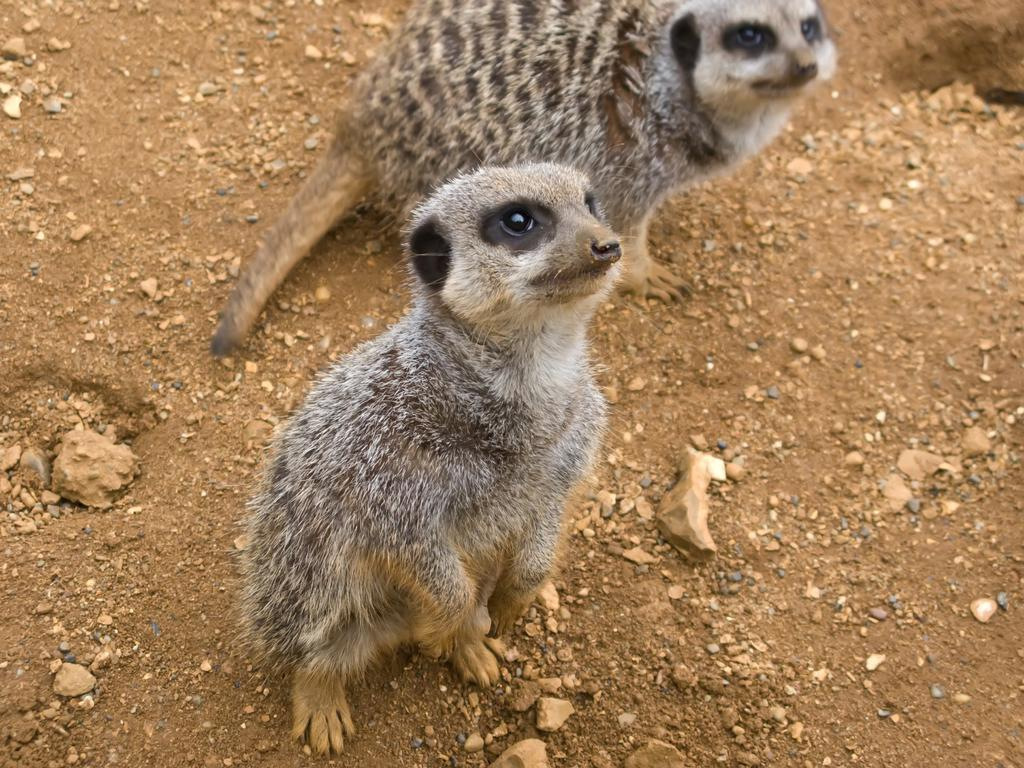How many animals are present in the image? There are two animals in the image. Where are the animals located in the image? The animals are on the ground. What is the tendency of the lock in the image? There is no lock present in the image, so it is not possible to determine its tendency. 